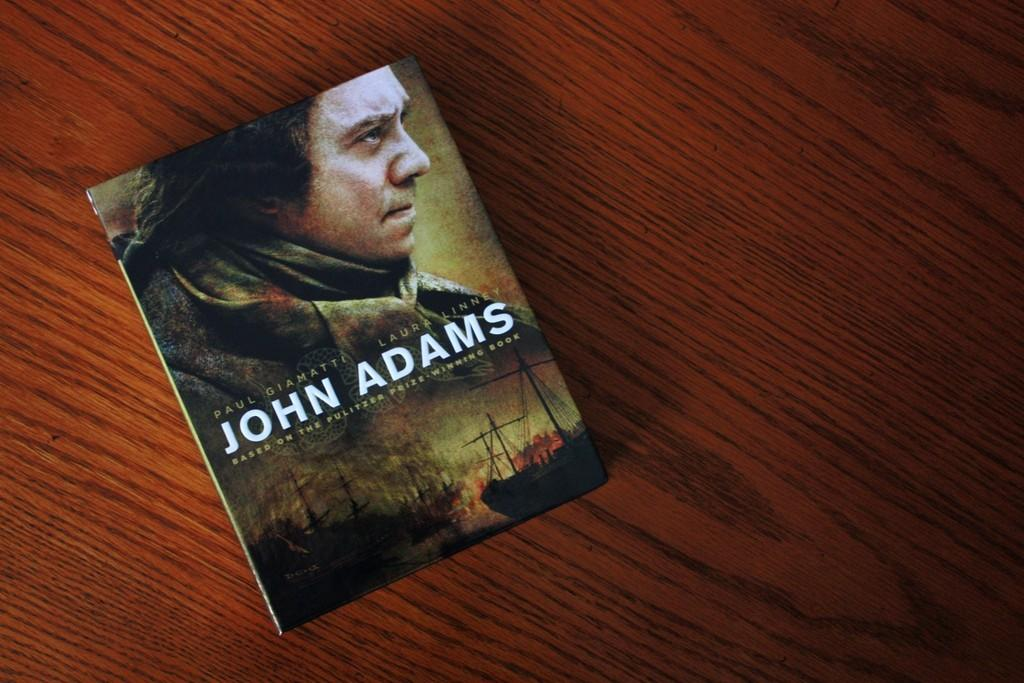What object is placed on the table in the image? There is a book on the table in the image. What is depicted on the book's cover? There is a man's photo on the book. What can be seen in the background of the image? There are ships in the water in the image. What name is written on the book? The book has "JOHN ADAMS" written on it. What unit of measurement is used to describe the size of the ships in the image? The provided facts do not mention any unit of measurement for the ships, so it cannot be determined from the image. 